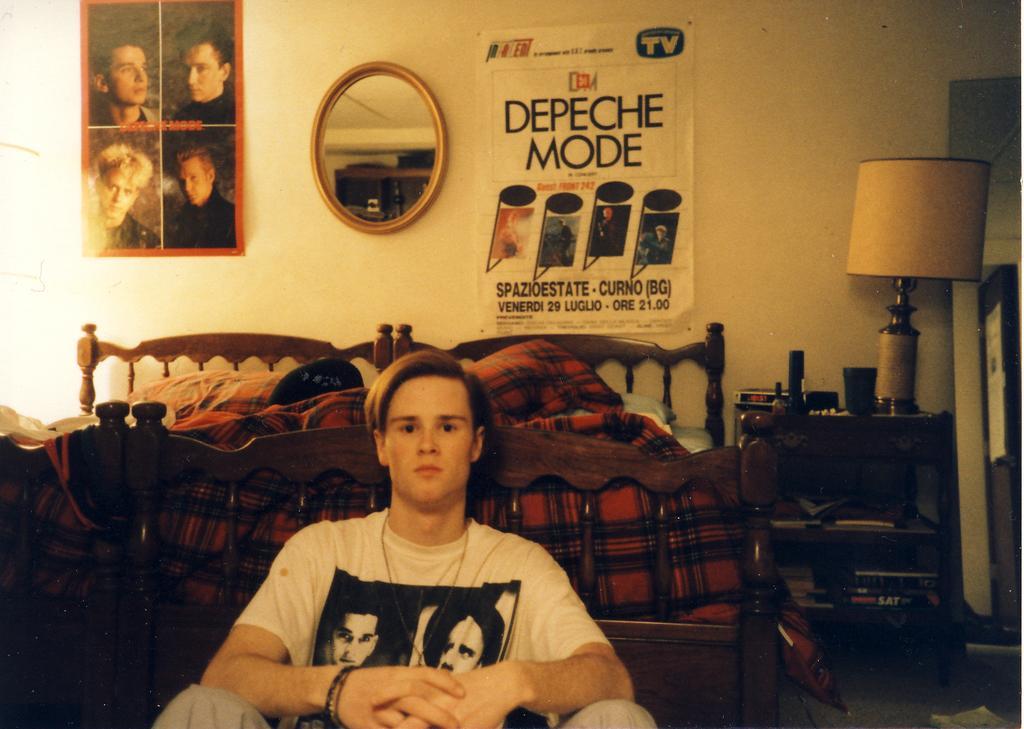Please provide a concise description of this image. In the picture i can see a person wearing white color T-shirt sitting on ground leaning to bed and i can see some pillows on bed, in the background of the picture there is a wall to which mirror and some posters are attached, on right side i can see a table on which there is lamp, there are some products on the table. 